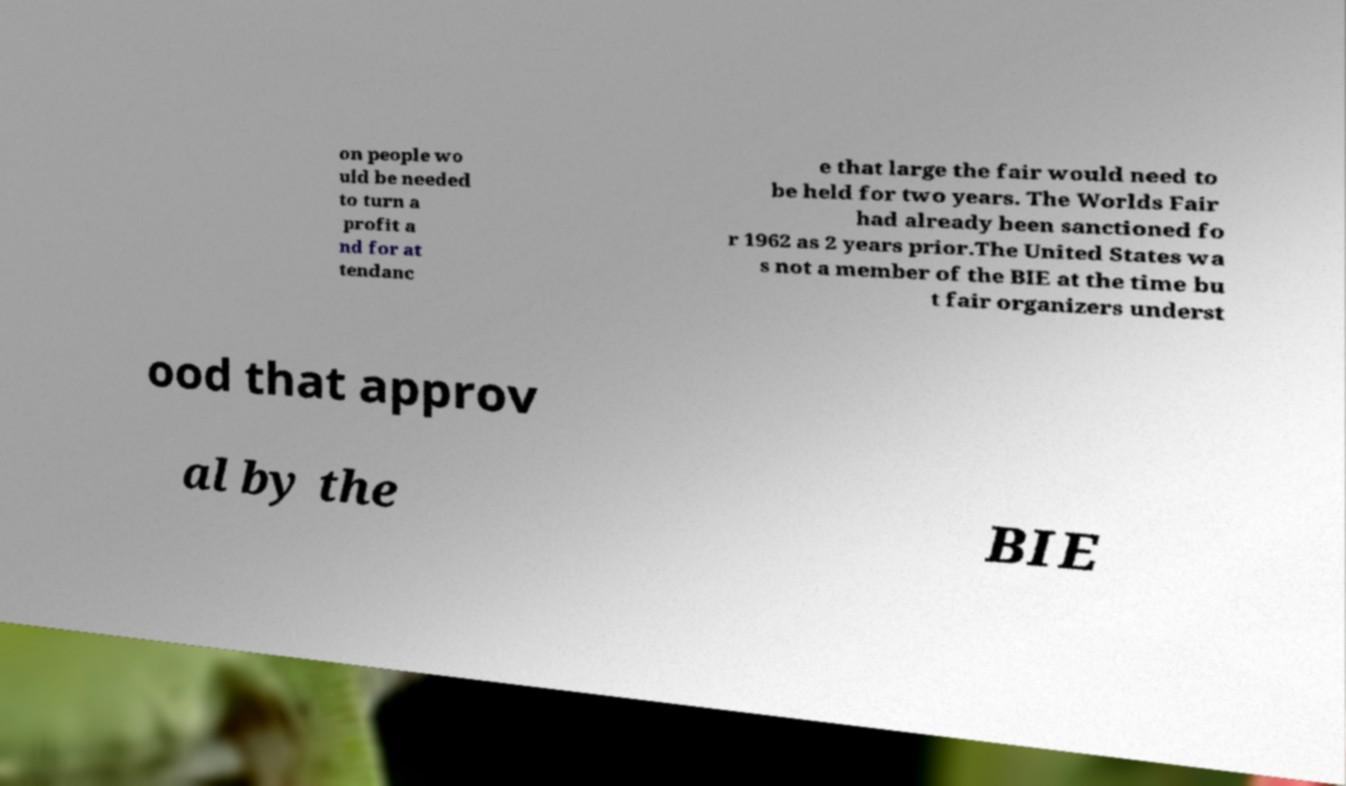Could you extract and type out the text from this image? on people wo uld be needed to turn a profit a nd for at tendanc e that large the fair would need to be held for two years. The Worlds Fair had already been sanctioned fo r 1962 as 2 years prior.The United States wa s not a member of the BIE at the time bu t fair organizers underst ood that approv al by the BIE 